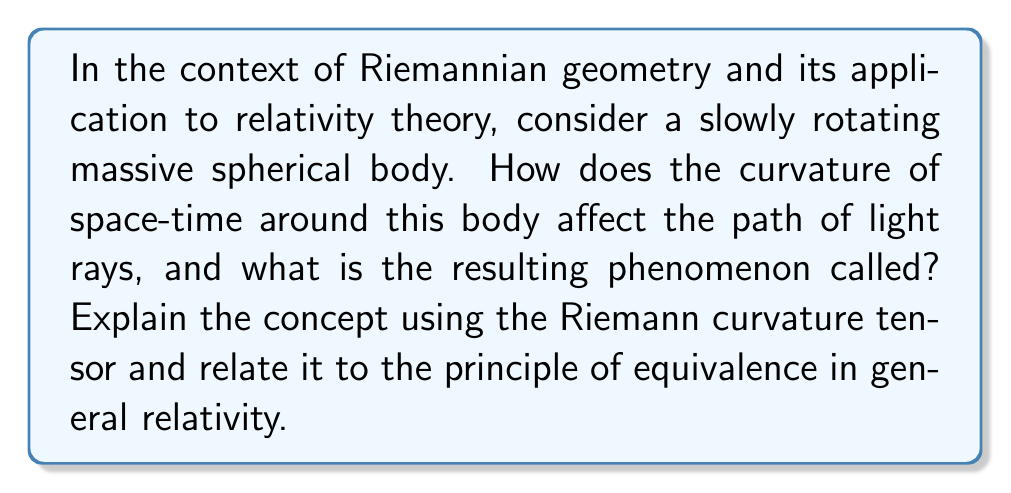Give your solution to this math problem. Let's approach this step-by-step:

1) In Riemannian geometry, curvature is described by the Riemann curvature tensor, $R^a_{bcd}$. This tensor measures how parallel transport of a vector around a closed loop fails to return to its original state.

2) In the context of general relativity, the curvature of space-time is directly related to the distribution of mass and energy. The Einstein field equations relate the curvature to the stress-energy tensor:

   $$R_{\mu\nu} - \frac{1}{2}Rg_{\mu\nu} + \Lambda g_{\mu\nu} = \frac{8\pi G}{c^4}T_{\mu\nu}$$

   where $R_{\mu\nu}$ is the Ricci tensor, $R$ is the scalar curvature, $g_{\mu\nu}$ is the metric tensor, $\Lambda$ is the cosmological constant, $G$ is Newton's gravitational constant, $c$ is the speed of light, and $T_{\mu\nu}$ is the stress-energy tensor.

3) For a massive spherical body, the space-time around it is curved. This curvature affects the path of light rays passing near the body. According to the principle of equivalence, gravity is indistinguishable from acceleration in a small local region of space-time.

4) As light passes near the massive body, it follows a geodesic in the curved space-time. This geodesic is not a straight line in the classical sense but the straightest possible path in curved space-time.

5) The result is that light rays appear to bend around the massive body. This phenomenon is called gravitational lensing.

6) For a slowly rotating body, there's an additional effect called frame-dragging or the Lense-Thirring effect. This causes light rays to twist slightly as they pass near the rotating body.

7) The amount of bending can be calculated using the Schwarzschild metric for non-rotating bodies or the Kerr metric for rotating bodies. The angle of deflection $\theta$ for a light ray passing a non-rotating spherical mass $M$ at a distance $r$ is approximately:

   $$\theta \approx \frac{4GM}{c^2r}$$

   where $G$ is the gravitational constant and $c$ is the speed of light.

8) This bending of light was one of the first experimental confirmations of general relativity, observed during a solar eclipse in 1919 by Arthur Eddington.
Answer: Gravitational lensing 